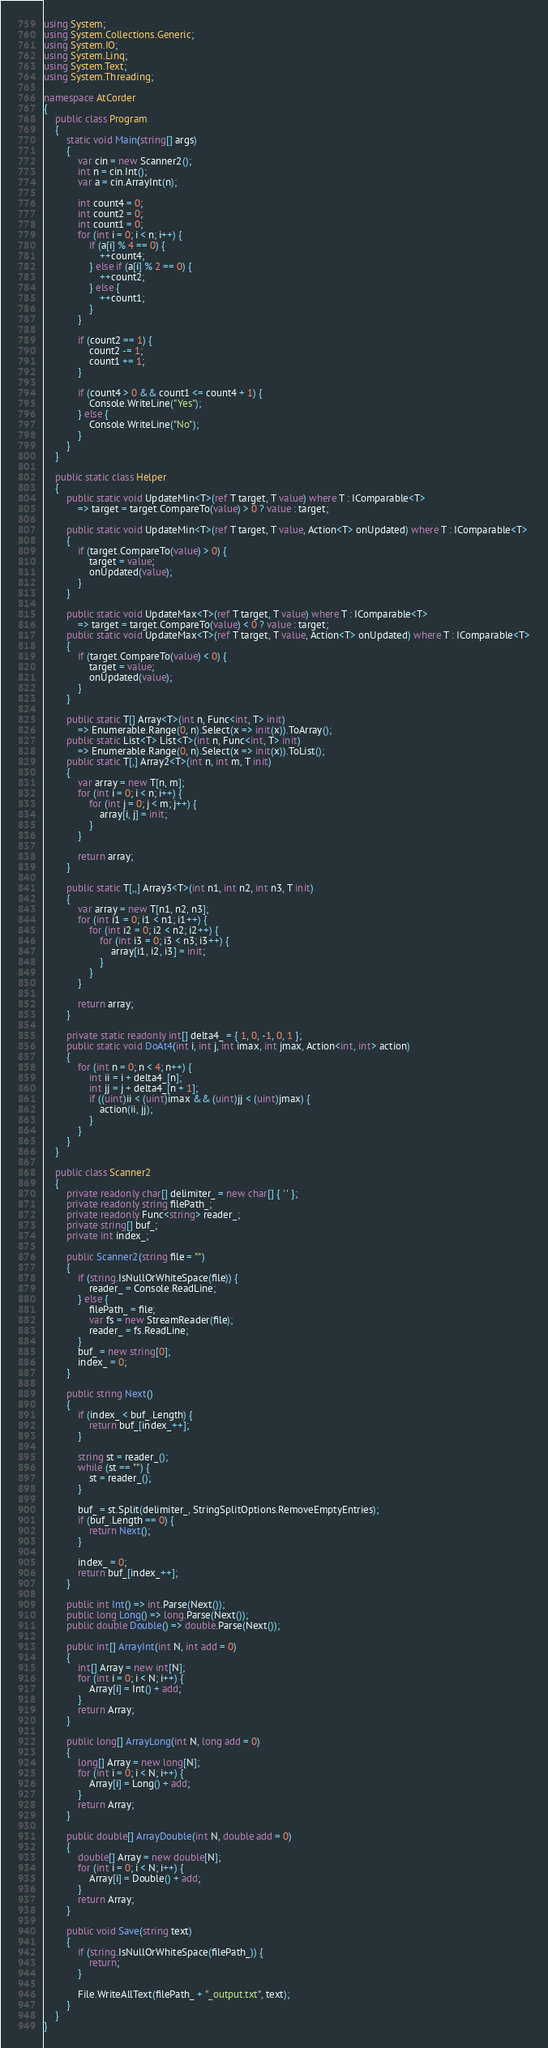Convert code to text. <code><loc_0><loc_0><loc_500><loc_500><_C#_>using System;
using System.Collections.Generic;
using System.IO;
using System.Linq;
using System.Text;
using System.Threading;

namespace AtCorder
{
	public class Program
	{
		static void Main(string[] args)
		{
			var cin = new Scanner2();
			int n = cin.Int();
			var a = cin.ArrayInt(n);

			int count4 = 0;
			int count2 = 0;
			int count1 = 0;
			for (int i = 0; i < n; i++) {
				if (a[i] % 4 == 0) {
					++count4;
				} else if (a[i] % 2 == 0) {
					++count2;
				} else {
					++count1;
				}
			}

			if (count2 == 1) {
				count2 -= 1;
				count1 += 1;
			}

			if (count4 > 0 && count1 <= count4 + 1) {
				Console.WriteLine("Yes");
			} else {
				Console.WriteLine("No");
			}
		}
	}

	public static class Helper
	{
		public static void UpdateMin<T>(ref T target, T value) where T : IComparable<T>
			=> target = target.CompareTo(value) > 0 ? value : target;

		public static void UpdateMin<T>(ref T target, T value, Action<T> onUpdated) where T : IComparable<T>
		{
			if (target.CompareTo(value) > 0) {
				target = value;
				onUpdated(value);
			}
		}

		public static void UpdateMax<T>(ref T target, T value) where T : IComparable<T>
			=> target = target.CompareTo(value) < 0 ? value : target;
		public static void UpdateMax<T>(ref T target, T value, Action<T> onUpdated) where T : IComparable<T>
		{
			if (target.CompareTo(value) < 0) {
				target = value;
				onUpdated(value);
			}
		}

		public static T[] Array<T>(int n, Func<int, T> init)
			=> Enumerable.Range(0, n).Select(x => init(x)).ToArray();
		public static List<T> List<T>(int n, Func<int, T> init)
			=> Enumerable.Range(0, n).Select(x => init(x)).ToList();
		public static T[,] Array2<T>(int n, int m, T init)
		{
			var array = new T[n, m];
			for (int i = 0; i < n; i++) {
				for (int j = 0; j < m; j++) {
					array[i, j] = init;
				}
			}

			return array;
		}

		public static T[,,] Array3<T>(int n1, int n2, int n3, T init)
		{
			var array = new T[n1, n2, n3];
			for (int i1 = 0; i1 < n1; i1++) {
				for (int i2 = 0; i2 < n2; i2++) {
					for (int i3 = 0; i3 < n3; i3++) {
						array[i1, i2, i3] = init;
					}
				}
			}

			return array;
		}

		private static readonly int[] delta4_ = { 1, 0, -1, 0, 1 };
		public static void DoAt4(int i, int j, int imax, int jmax, Action<int, int> action)
		{
			for (int n = 0; n < 4; n++) {
				int ii = i + delta4_[n];
				int jj = j + delta4_[n + 1];
				if ((uint)ii < (uint)imax && (uint)jj < (uint)jmax) {
					action(ii, jj);
				}
			}
		}
	}

	public class Scanner2
	{
		private readonly char[] delimiter_ = new char[] { ' ' };
		private readonly string filePath_;
		private readonly Func<string> reader_;
		private string[] buf_;
		private int index_;

		public Scanner2(string file = "")
		{
			if (string.IsNullOrWhiteSpace(file)) {
				reader_ = Console.ReadLine;
			} else {
				filePath_ = file;
				var fs = new StreamReader(file);
				reader_ = fs.ReadLine;
			}
			buf_ = new string[0];
			index_ = 0;
		}

		public string Next()
		{
			if (index_ < buf_.Length) {
				return buf_[index_++];
			}

			string st = reader_();
			while (st == "") {
				st = reader_();
			}

			buf_ = st.Split(delimiter_, StringSplitOptions.RemoveEmptyEntries);
			if (buf_.Length == 0) {
				return Next();
			}

			index_ = 0;
			return buf_[index_++];
		}

		public int Int() => int.Parse(Next());
		public long Long() => long.Parse(Next());
		public double Double() => double.Parse(Next());

		public int[] ArrayInt(int N, int add = 0)
		{
			int[] Array = new int[N];
			for (int i = 0; i < N; i++) {
				Array[i] = Int() + add;
			}
			return Array;
		}

		public long[] ArrayLong(int N, long add = 0)
		{
			long[] Array = new long[N];
			for (int i = 0; i < N; i++) {
				Array[i] = Long() + add;
			}
			return Array;
		}

		public double[] ArrayDouble(int N, double add = 0)
		{
			double[] Array = new double[N];
			for (int i = 0; i < N; i++) {
				Array[i] = Double() + add;
			}
			return Array;
		}

		public void Save(string text)
		{
			if (string.IsNullOrWhiteSpace(filePath_)) {
				return;
			}

			File.WriteAllText(filePath_ + "_output.txt", text);
		}
	}
}</code> 